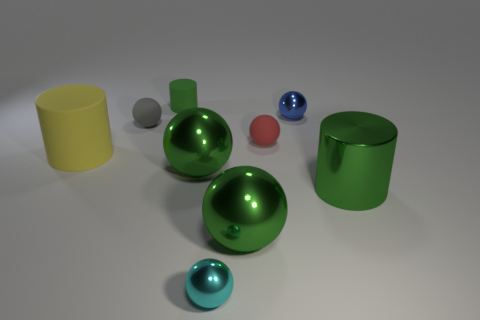What materials do the objects in the image appear to be made of? The objects in the image seem to be made of different materials. The cylinders and balls exhibit reflective properties that suggest they could be made of metals or polished plastics. The surfaces are smooth and shiny, indicating they might be simulations designed to show how light interacts with objects of varying colors and materials. 